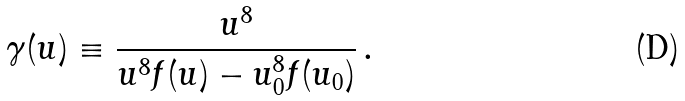Convert formula to latex. <formula><loc_0><loc_0><loc_500><loc_500>\gamma ( u ) \equiv \frac { u ^ { 8 } } { u ^ { 8 } f ( u ) - u _ { 0 } ^ { 8 } f ( u _ { 0 } ) } \, .</formula> 